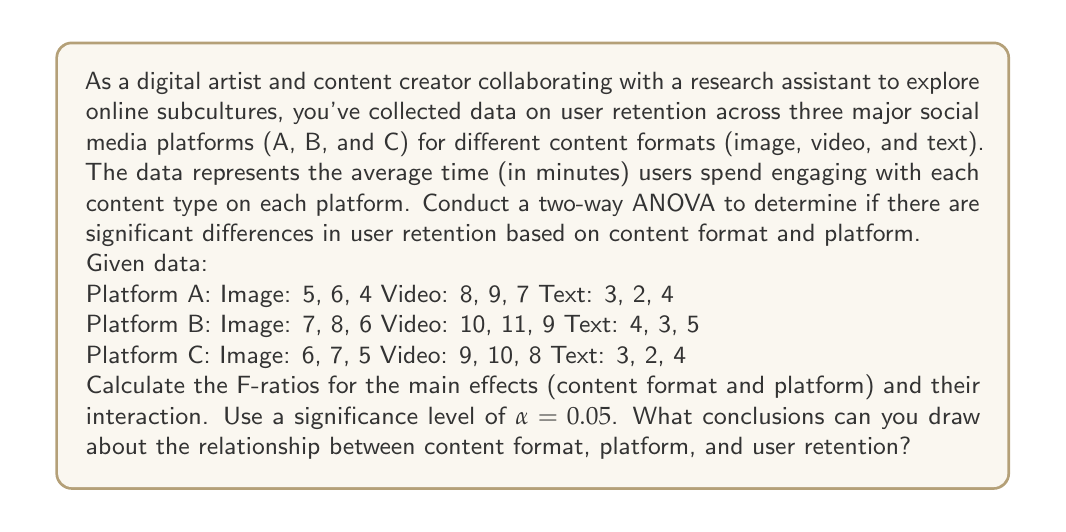What is the answer to this math problem? To conduct a two-way ANOVA, we need to follow these steps:

1. Calculate the sum of squares for each source of variation:
   - Total Sum of Squares (SST)
   - Sum of Squares for Factor A (SSA) - Content Format
   - Sum of Squares for Factor B (SSB) - Platform
   - Sum of Squares for Interaction (SSAB)
   - Sum of Squares for Error (SSE)

2. Calculate the degrees of freedom for each source of variation
3. Calculate the Mean Square for each source of variation
4. Calculate the F-ratios
5. Compare the F-ratios to the critical F-values

Step 1: Calculate Sum of Squares

First, we need to calculate the grand mean:
$$\bar{X} = \frac{\text{Sum of all observations}}{\text{Total number of observations}} = \frac{165}{27} = 6.11$$

Now, we can calculate the sum of squares:

SST = $\sum_{i=1}^{3}\sum_{j=1}^{3}\sum_{k=1}^{3} (X_{ijk} - \bar{X})^2 = 228.89$

SSA = $3 \times 3 \times \sum_{i=1}^{3} (\bar{X}_i - \bar{X})^2 = 135.56$

SSB = $3 \times 3 \times \sum_{j=1}^{3} (\bar{X}_j - \bar{X})^2 = 18.67$

SSAB = $3 \times \sum_{i=1}^{3}\sum_{j=1}^{3} (\bar{X}_{ij} - \bar{X}_i - \bar{X}_j + \bar{X})^2 = 0.44$

SSE = SST - SSA - SSB - SSAB = 74.22

Step 2: Calculate Degrees of Freedom

df_A = 2 (3 content formats - 1)
df_B = 2 (3 platforms - 1)
df_AB = 4 (df_A × df_B)
df_E = 18 (27 total observations - 9 groups)
df_T = 26 (27 total observations - 1)

Step 3: Calculate Mean Squares

MSA = SSA / df_A = 67.78
MSB = SSB / df_B = 9.33
MSAB = SSAB / df_AB = 0.11
MSE = SSE / df_E = 4.12

Step 4: Calculate F-ratios

F_A = MSA / MSE = 16.44
F_B = MSB / MSE = 2.26
F_AB = MSAB / MSE = 0.03

Step 5: Compare F-ratios to critical F-values

Using an F-distribution table with α = 0.05:
F_crit(2, 18) ≈ 3.55
F_crit(4, 18) ≈ 2.93

Conclusions:
1. Content Format (Factor A): F_A = 16.44 > F_crit(2, 18) = 3.55
   There is a significant effect of content format on user retention.

2. Platform (Factor B): F_B = 2.26 < F_crit(2, 18) = 3.55
   There is no significant effect of platform on user retention.

3. Interaction (AB): F_AB = 0.03 < F_crit(4, 18) = 2.93
   There is no significant interaction effect between content format and platform on user retention.
Answer: The two-way ANOVA results indicate:

1. Content format has a significant effect on user retention (F = 16.44, p < 0.05).
2. Platform does not have a significant effect on user retention (F = 2.26, p > 0.05).
3. There is no significant interaction between content format and platform (F = 0.03, p > 0.05).

These findings suggest that the type of content (image, video, or text) significantly influences user retention across platforms, while the choice of platform itself does not have a significant impact. Additionally, the relationship between content format and user retention is consistent across different platforms. 